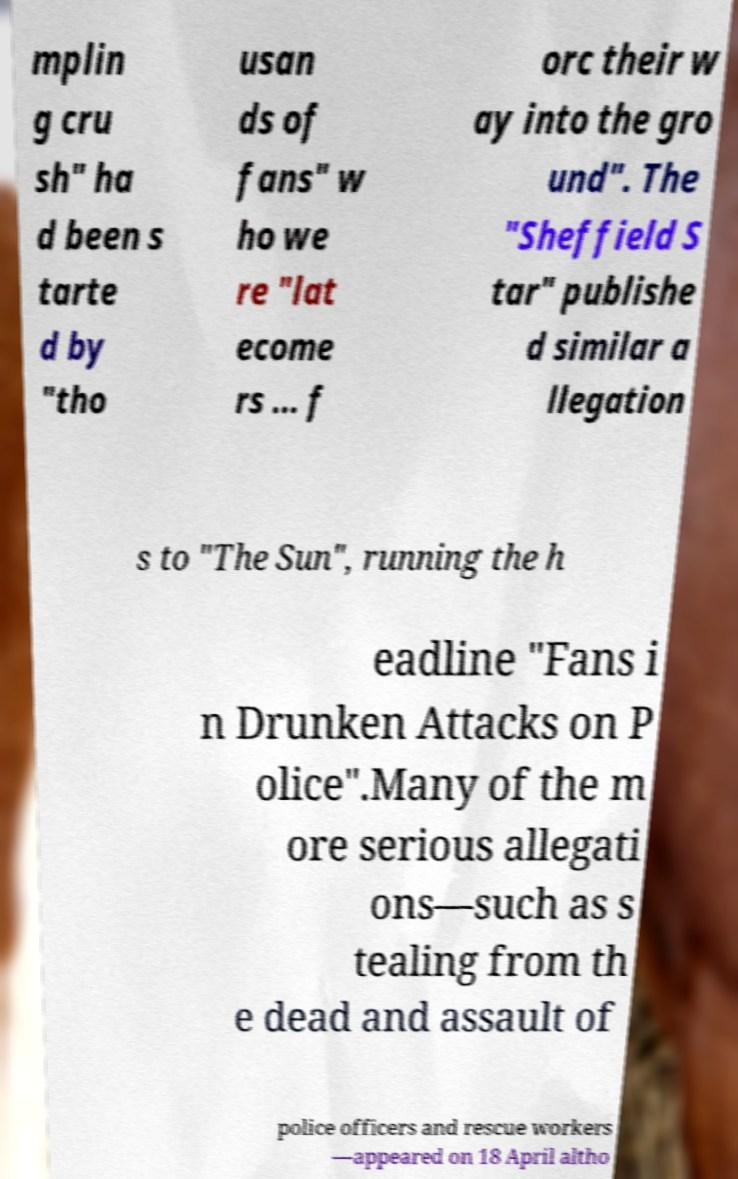Can you read and provide the text displayed in the image?This photo seems to have some interesting text. Can you extract and type it out for me? mplin g cru sh" ha d been s tarte d by "tho usan ds of fans" w ho we re "lat ecome rs ... f orc their w ay into the gro und". The "Sheffield S tar" publishe d similar a llegation s to "The Sun", running the h eadline "Fans i n Drunken Attacks on P olice".Many of the m ore serious allegati ons—such as s tealing from th e dead and assault of police officers and rescue workers —appeared on 18 April altho 